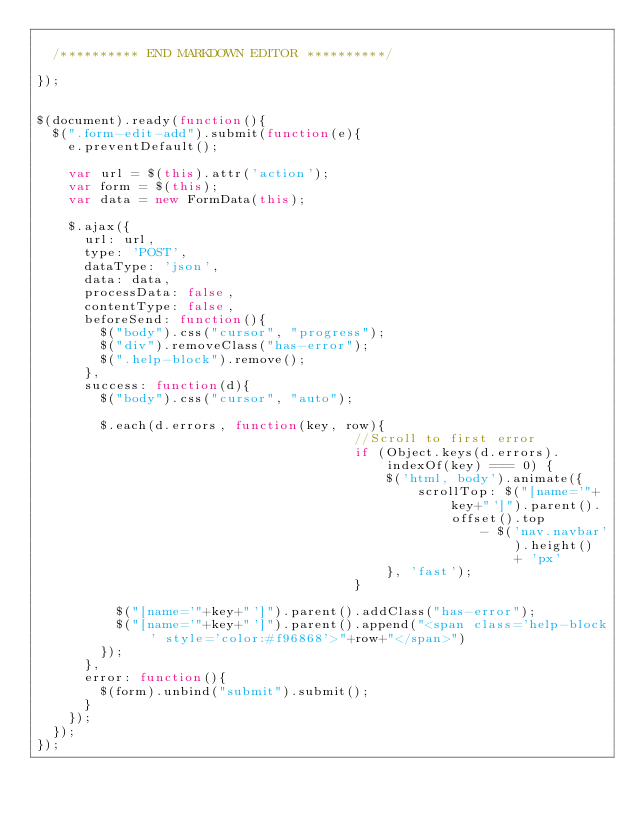<code> <loc_0><loc_0><loc_500><loc_500><_JavaScript_>
  /********** END MARKDOWN EDITOR **********/

});


$(document).ready(function(){
  $(".form-edit-add").submit(function(e){
    e.preventDefault();

    var url = $(this).attr('action');
    var form = $(this);
    var data = new FormData(this);

    $.ajax({
      url: url,
      type: 'POST',
      dataType: 'json',
      data: data,
      processData: false,
      contentType: false,
      beforeSend: function(){
        $("body").css("cursor", "progress");
        $("div").removeClass("has-error");
        $(".help-block").remove();
      },
      success: function(d){
        $("body").css("cursor", "auto");

        $.each(d.errors, function(key, row){
                                        //Scroll to first error
                                        if (Object.keys(d.errors).indexOf(key) === 0) {
                                            $('html, body').animate({
                                                scrollTop: $("[name='"+key+"']").parent().offset().top
                                                        - $('nav.navbar').height() + 'px'
                                            }, 'fast');
                                        }

          $("[name='"+key+"']").parent().addClass("has-error");
          $("[name='"+key+"']").parent().append("<span class='help-block' style='color:#f96868'>"+row+"</span>")
        });
      },
      error: function(){
        $(form).unbind("submit").submit();
      }
    });
  });
});
</code> 